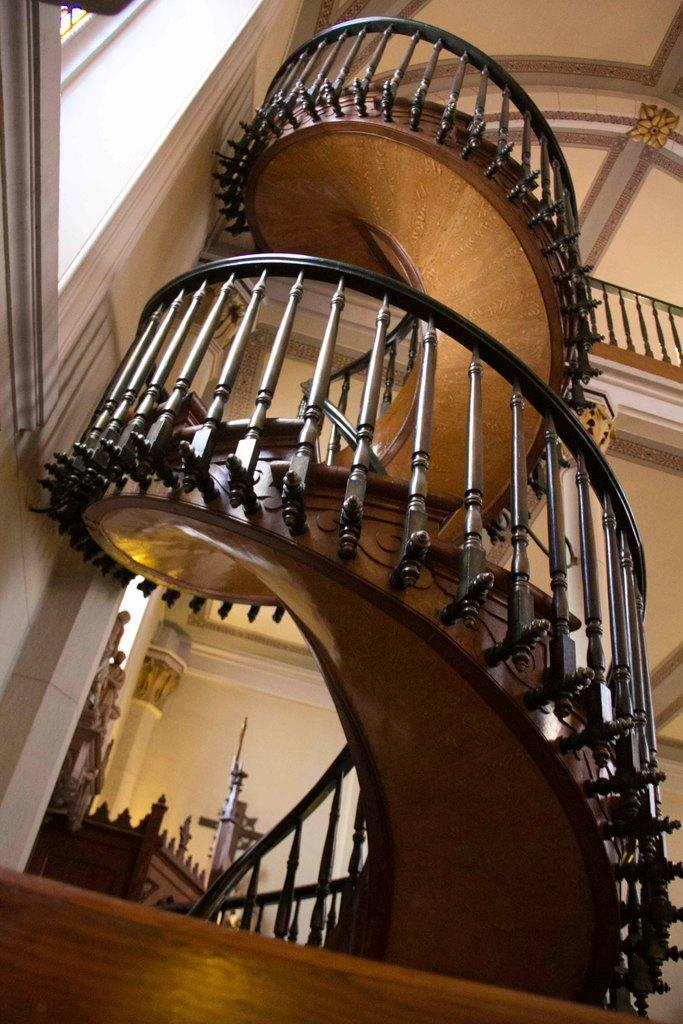What type of structure is present in the image? There is a building in the image. What is the color of the building? The building is cream in color. What architectural feature can be seen in the image? There is a staircase in the image. What safety feature is present in the image? There is a railing in the image. What type of surface can be seen in the image? There is a brown colored surface in the image. What song is being sung by the men in the image? There are no men or any indication of singing in the image. 